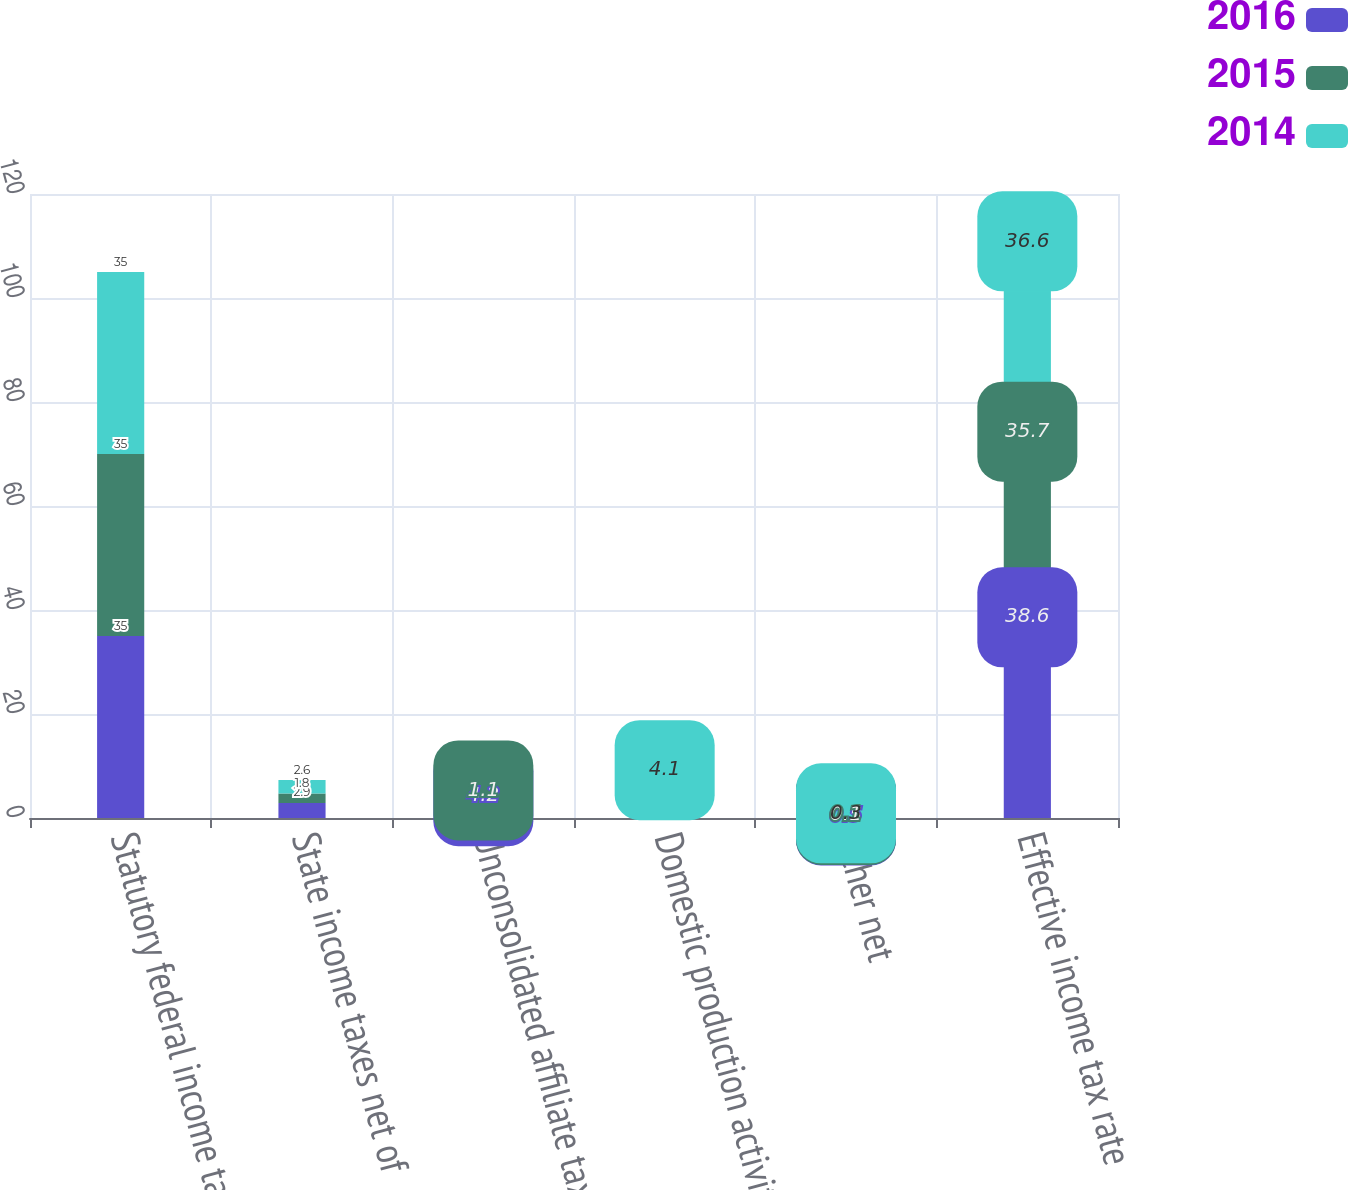Convert chart to OTSL. <chart><loc_0><loc_0><loc_500><loc_500><stacked_bar_chart><ecel><fcel>Statutory federal income tax<fcel>State income taxes net of<fcel>Unconsolidated affiliate tax<fcel>Domestic production activities<fcel>Other net<fcel>Effective income tax rate<nl><fcel>2016<fcel>35<fcel>2.9<fcel>4.2<fcel>3<fcel>0.5<fcel>38.6<nl><fcel>2015<fcel>35<fcel>1.8<fcel>1.1<fcel>2.1<fcel>0.1<fcel>35.7<nl><fcel>2014<fcel>35<fcel>2.6<fcel>3.4<fcel>4.1<fcel>0.3<fcel>36.6<nl></chart> 